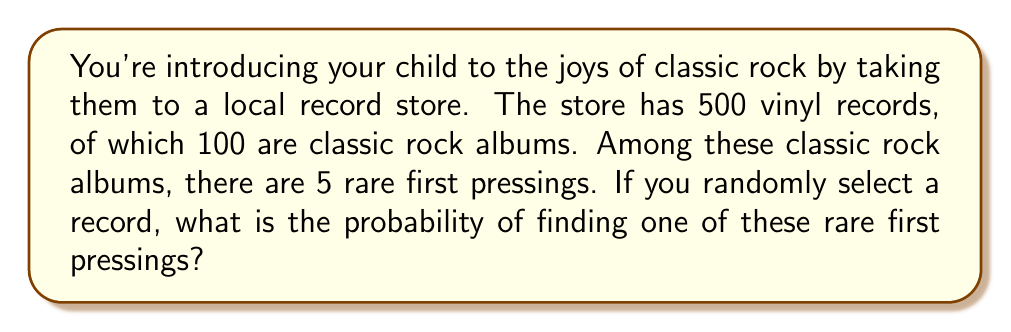Provide a solution to this math problem. Let's approach this step-by-step:

1) First, we need to identify the total number of possible outcomes and the number of favorable outcomes:
   - Total number of records: 500
   - Number of rare first pressings: 5

2) The probability of an event is calculated by dividing the number of favorable outcomes by the total number of possible outcomes:

   $$P(\text{event}) = \frac{\text{number of favorable outcomes}}{\text{total number of possible outcomes}}$$

3) In this case:
   $$P(\text{rare first pressing}) = \frac{5}{500}$$

4) To simplify this fraction:
   $$\frac{5}{500} = \frac{1}{100} = 0.01$$

5) To express this as a percentage:
   $$0.01 \times 100\% = 1\%$$

Therefore, the probability of randomly selecting a rare first pressing is 1% or 0.01.
Answer: $\frac{1}{100}$ or 0.01 or 1% 